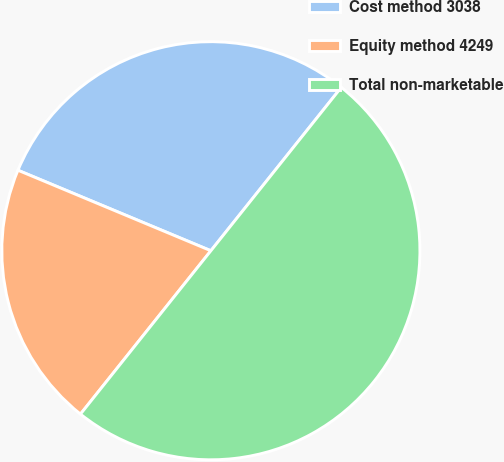Convert chart. <chart><loc_0><loc_0><loc_500><loc_500><pie_chart><fcel>Cost method 3038<fcel>Equity method 4249<fcel>Total non-marketable<nl><fcel>29.43%<fcel>20.57%<fcel>50.0%<nl></chart> 